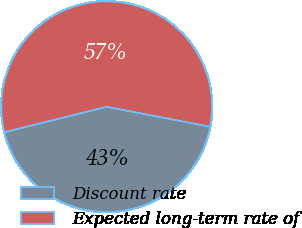Convert chart to OTSL. <chart><loc_0><loc_0><loc_500><loc_500><pie_chart><fcel>Discount rate<fcel>Expected long-term rate of<nl><fcel>43.09%<fcel>56.91%<nl></chart> 